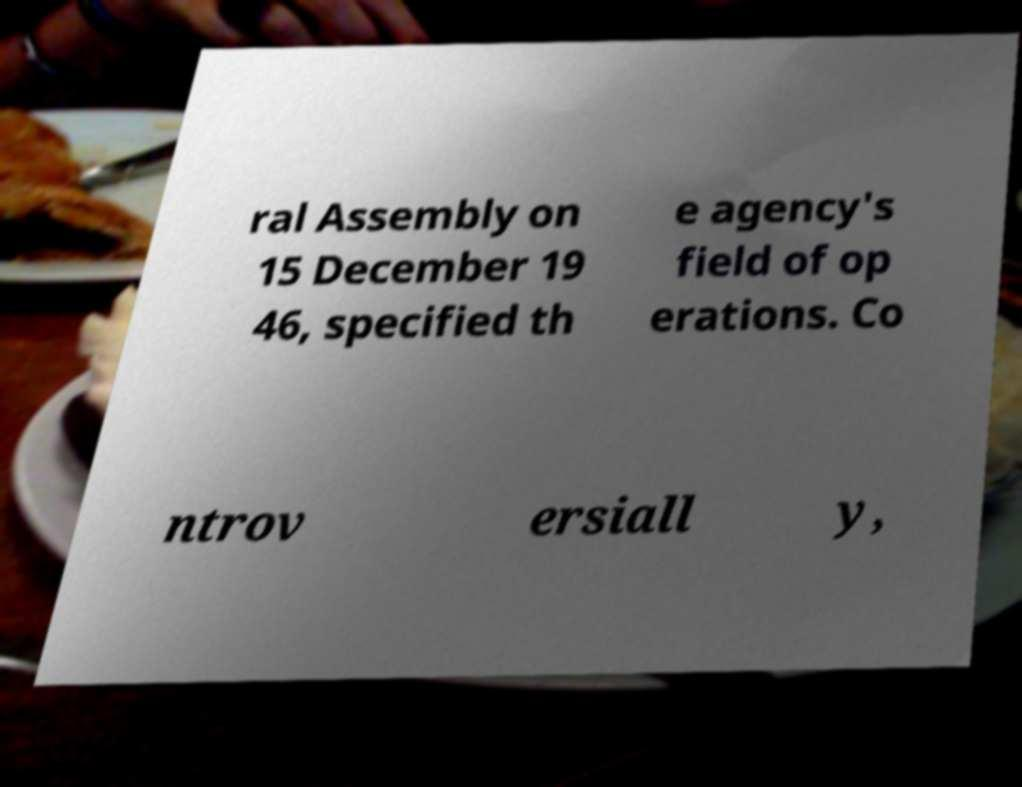Could you assist in decoding the text presented in this image and type it out clearly? ral Assembly on 15 December 19 46, specified th e agency's field of op erations. Co ntrov ersiall y, 